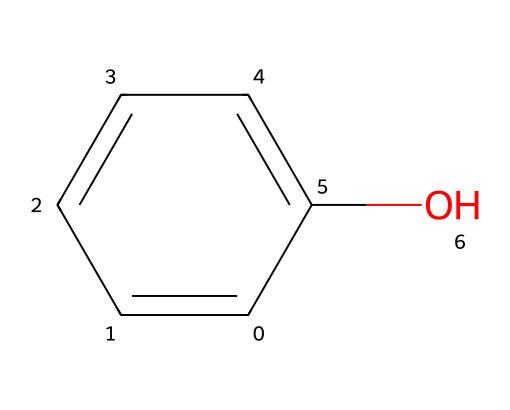What is the name of this chemical? The SMILES notation c1ccccc1O indicates a benzene ring with a hydroxyl group, which is characteristic of phenols. Therefore, the name of this chemical is derived from its structure as phenol.
Answer: phenol How many carbon atoms are present in this structure? The notation c1ccccc1 indicates that there is a six-membered carbon ring, which means there are six carbon atoms in the molecule.
Answer: six What functional group does this chemical contain? The presence of the hydroxyl group (-OH) indicated by the "O" in the SMILES notation identifies it as an alcohol functional group, which is a characteristic feature of phenols.
Answer: hydroxyl How many hydrogen atoms are bonded to the carbon atoms in this structure? Since there are six carbon atoms in the benzene ring and one of the hydrogen atoms is replaced by the hydroxyl group, there are five hydrogen atoms remaining attached to the carbon atoms. Therefore, the total number of hydrogen atoms is five.
Answer: five What is the hybridization state of the carbon atoms in this molecule? The carbon atoms in the benzene ring (aromatic system) are sp2 hybridized due to the presence of double bonds and resonance stabilization within the ring structure. Consulting the connectivity and bonds confirms this hybridization type as sp2.
Answer: sp2 What type of compound does this structure represent in terms of aromaticity? Given the cyclic structure, alternating double bonds, and complete delocalization of pi electrons in the benzene ring, this compound is classified as aromatic. The stability and structure aligns with the criteria for aromatic compounds.
Answer: aromatic What effect does the hydroxyl group have on the acidity of this compound? The presence of the hydroxyl group in phenol increases its acidity compared to other alcohols. This is because the -OH group can stabilize the conjugate base (phenoxide ion) through resonance, making phenol a weak acid.
Answer: increases acidity 